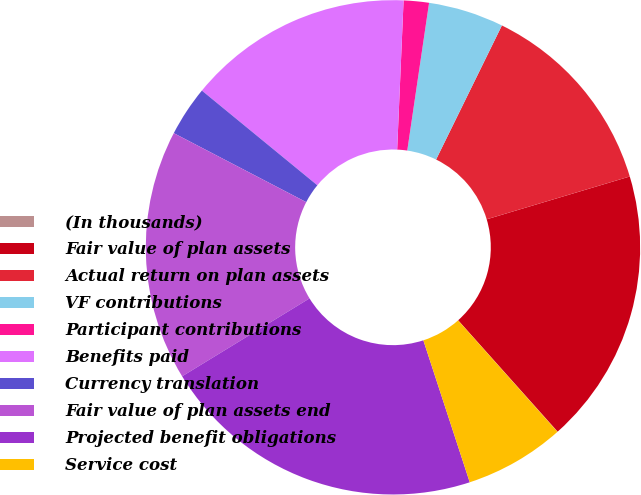<chart> <loc_0><loc_0><loc_500><loc_500><pie_chart><fcel>(In thousands)<fcel>Fair value of plan assets<fcel>Actual return on plan assets<fcel>VF contributions<fcel>Participant contributions<fcel>Benefits paid<fcel>Currency translation<fcel>Fair value of plan assets end<fcel>Projected benefit obligations<fcel>Service cost<nl><fcel>0.02%<fcel>18.02%<fcel>13.11%<fcel>4.93%<fcel>1.65%<fcel>14.75%<fcel>3.29%<fcel>16.38%<fcel>21.29%<fcel>6.56%<nl></chart> 